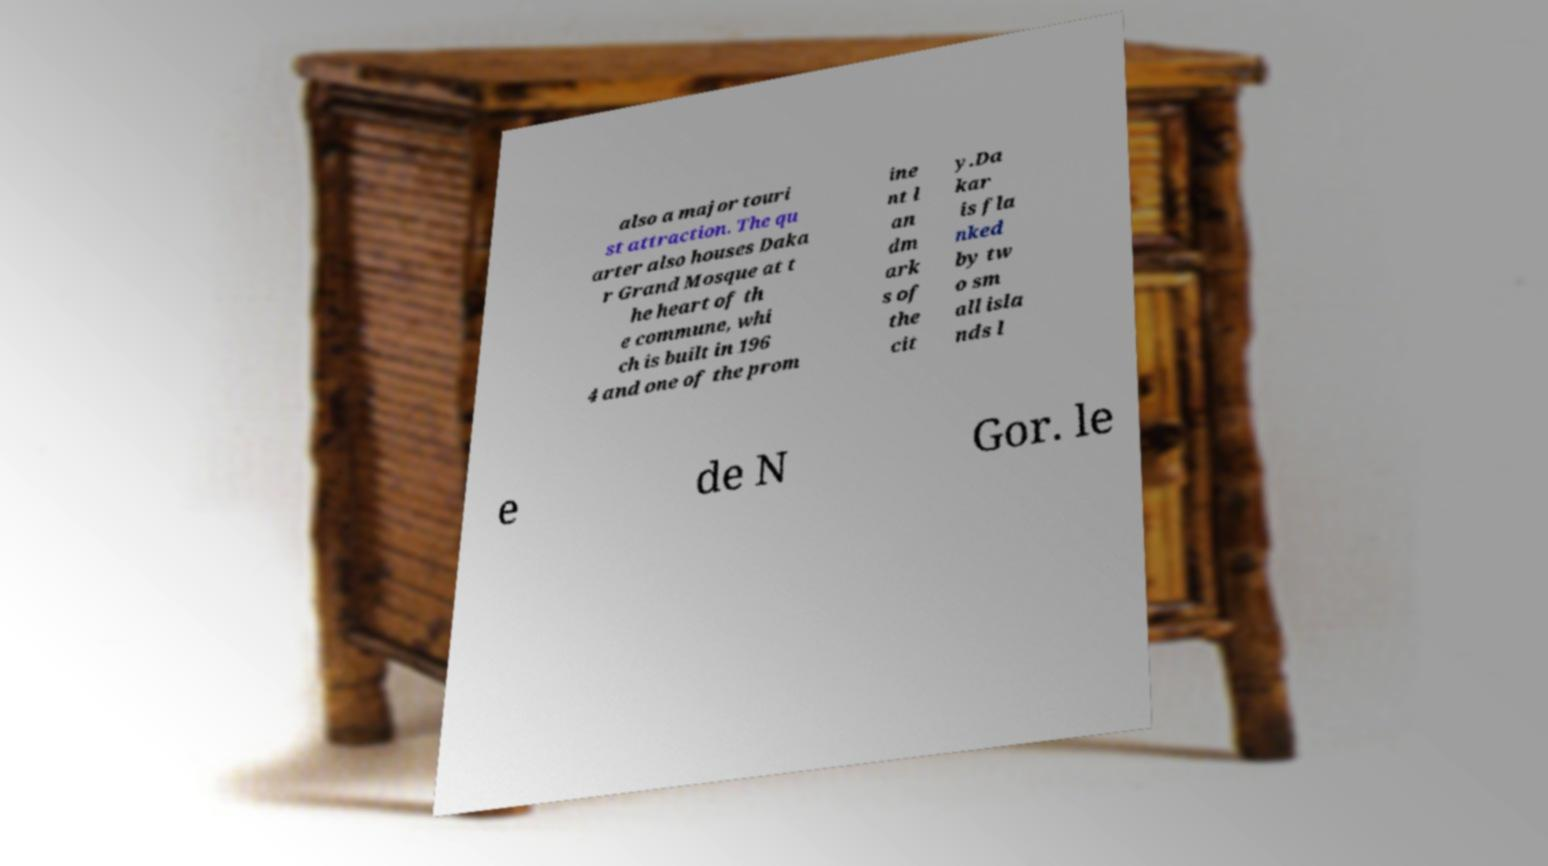Please identify and transcribe the text found in this image. also a major touri st attraction. The qu arter also houses Daka r Grand Mosque at t he heart of th e commune, whi ch is built in 196 4 and one of the prom ine nt l an dm ark s of the cit y.Da kar is fla nked by tw o sm all isla nds l e de N Gor. le 